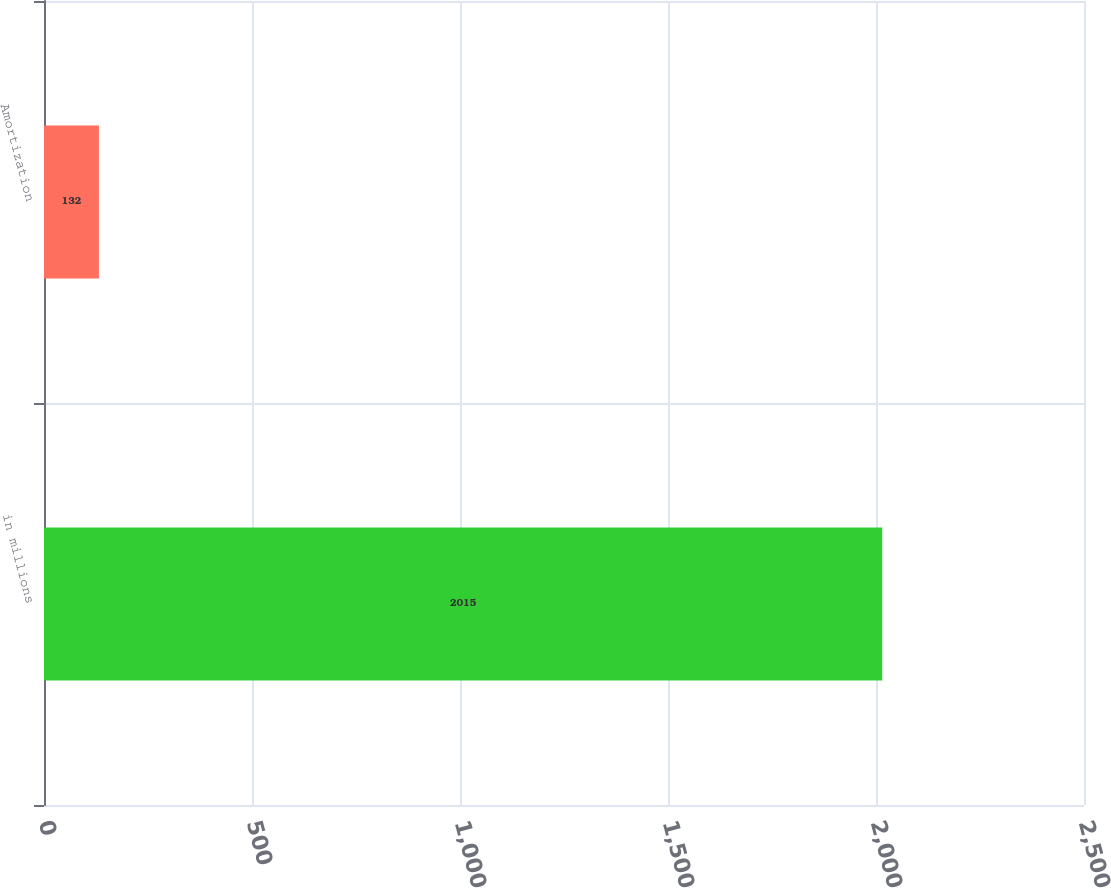Convert chart. <chart><loc_0><loc_0><loc_500><loc_500><bar_chart><fcel>in millions<fcel>Amortization<nl><fcel>2015<fcel>132<nl></chart> 